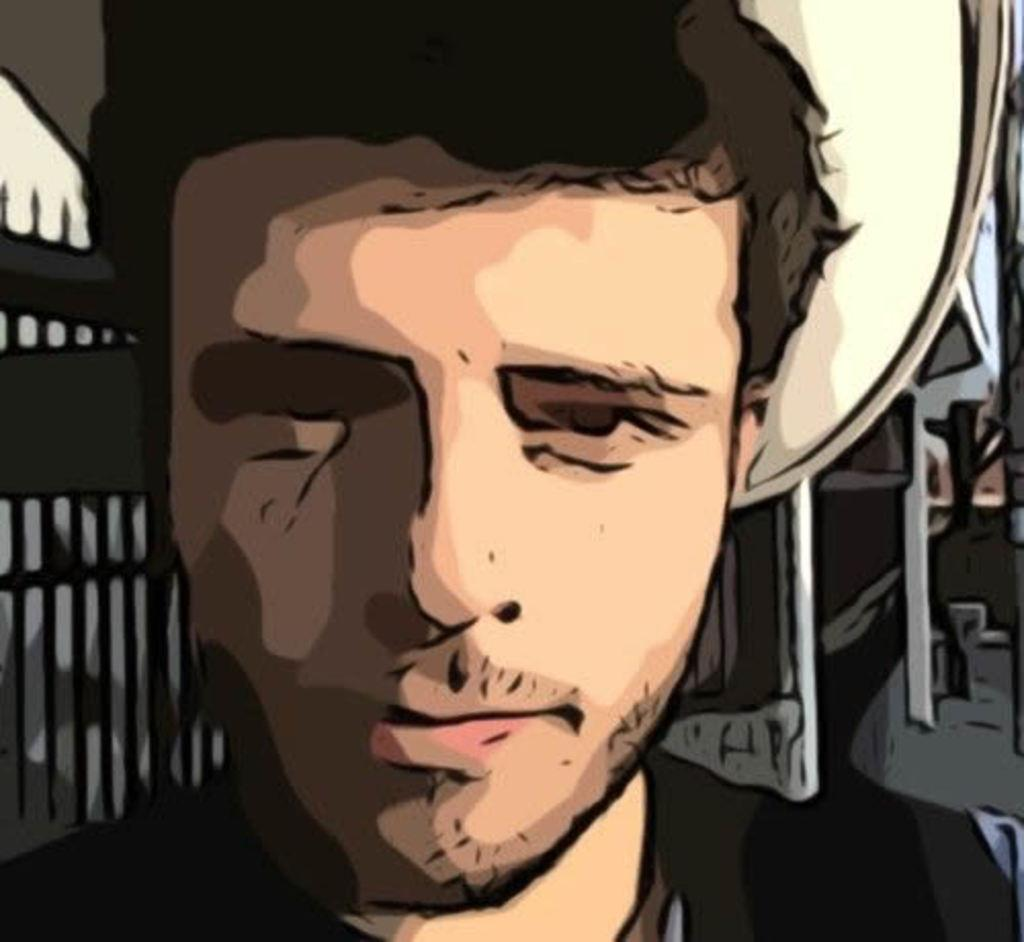What type of image is shown in the picture? There is an edited picture of a person in the image. What else can be seen in the image besides the edited picture? There is a building in the image. What type of dirt can be seen on the minister's shoes in the image? There is no minister or shoes present in the image, so it is not possible to determine what type of dirt might be on them. 